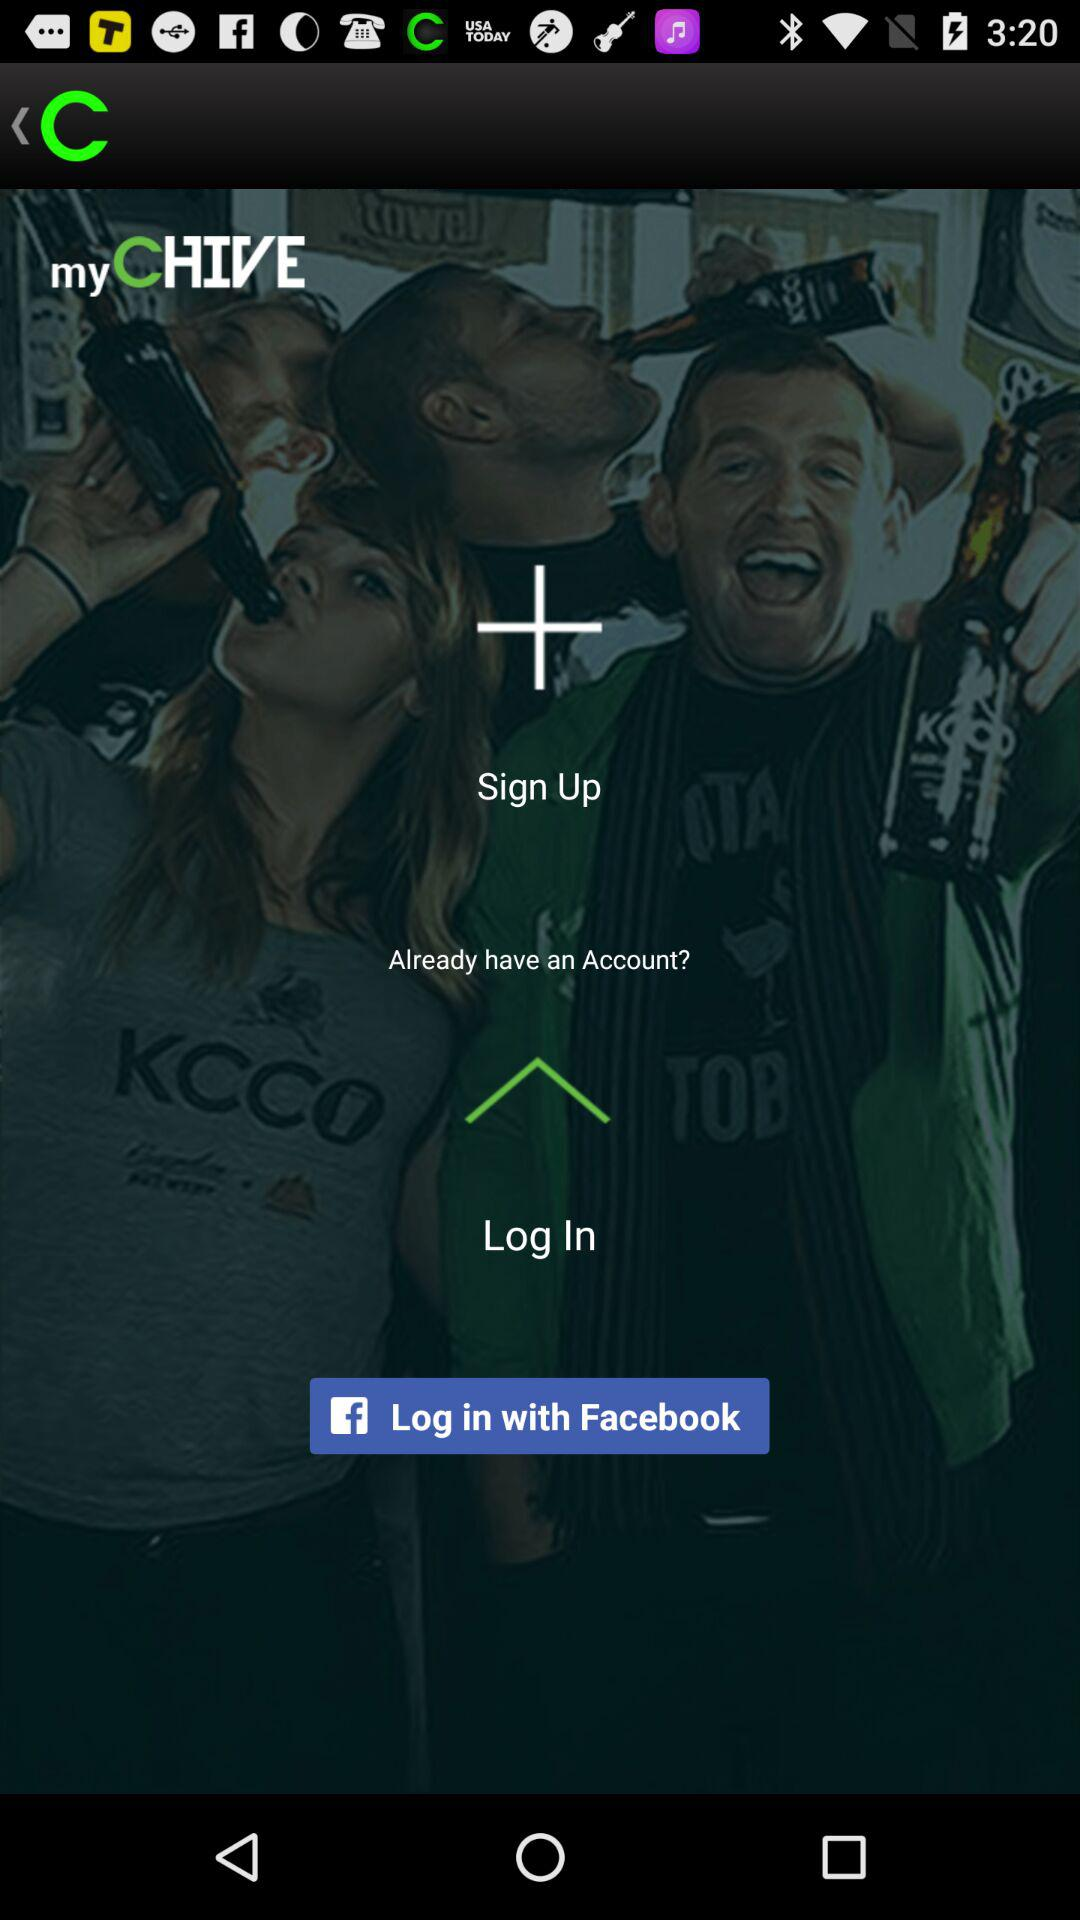What is the application name? The application names are "myCHIVE" and "Facebook". 